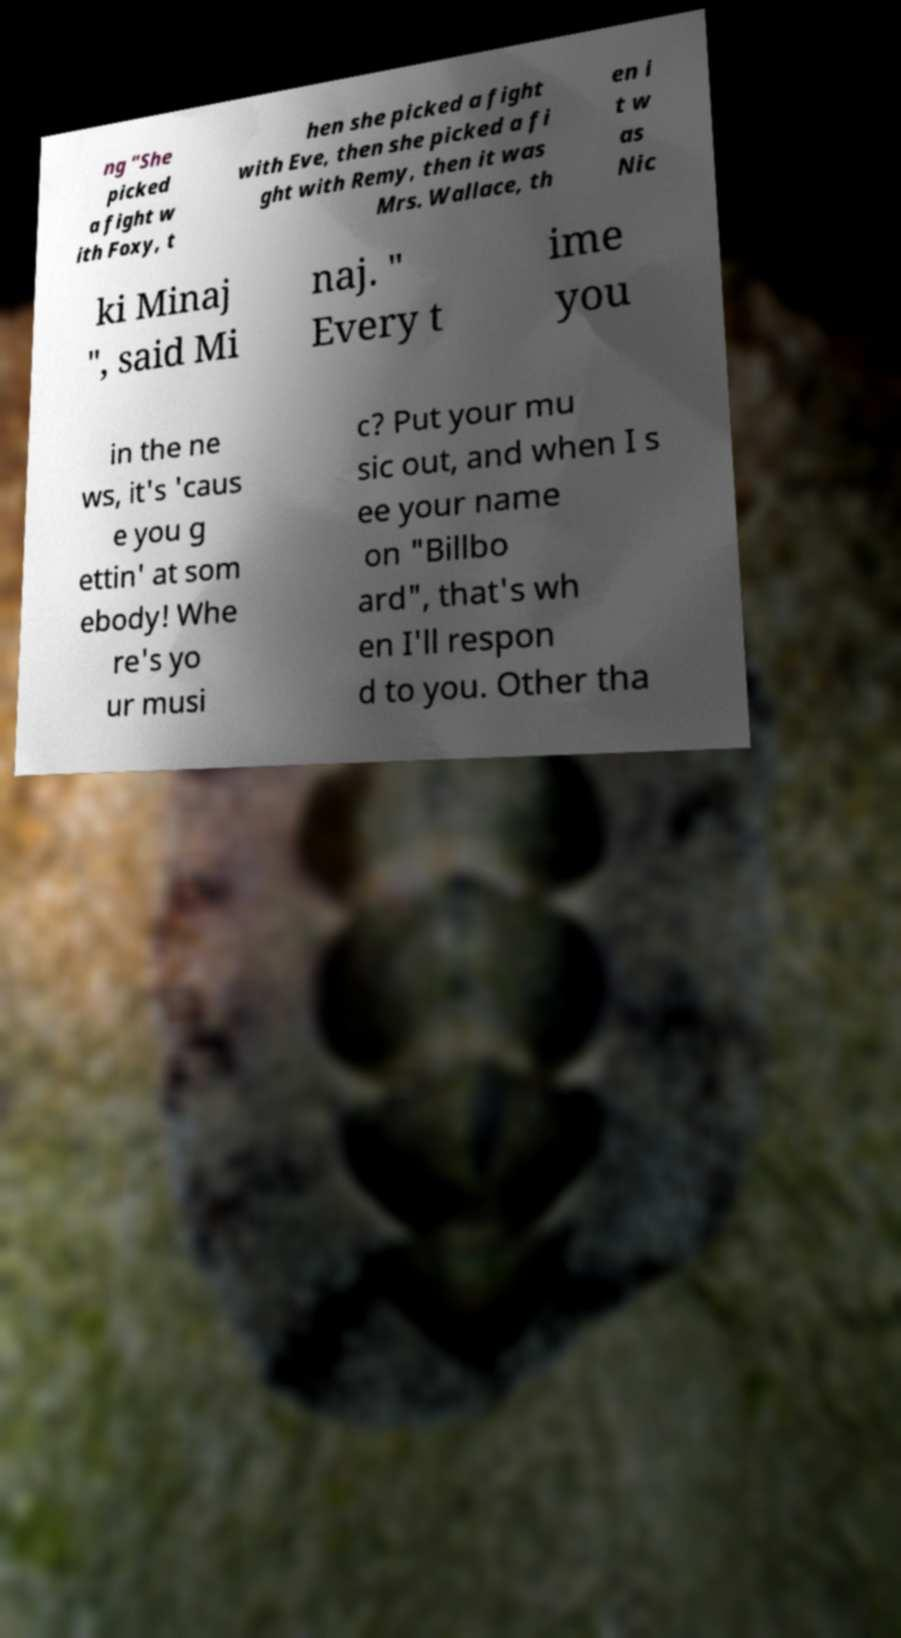Could you assist in decoding the text presented in this image and type it out clearly? ng "She picked a fight w ith Foxy, t hen she picked a fight with Eve, then she picked a fi ght with Remy, then it was Mrs. Wallace, th en i t w as Nic ki Minaj ", said Mi naj. " Every t ime you in the ne ws, it's 'caus e you g ettin' at som ebody! Whe re's yo ur musi c? Put your mu sic out, and when I s ee your name on "Billbo ard", that's wh en I'll respon d to you. Other tha 